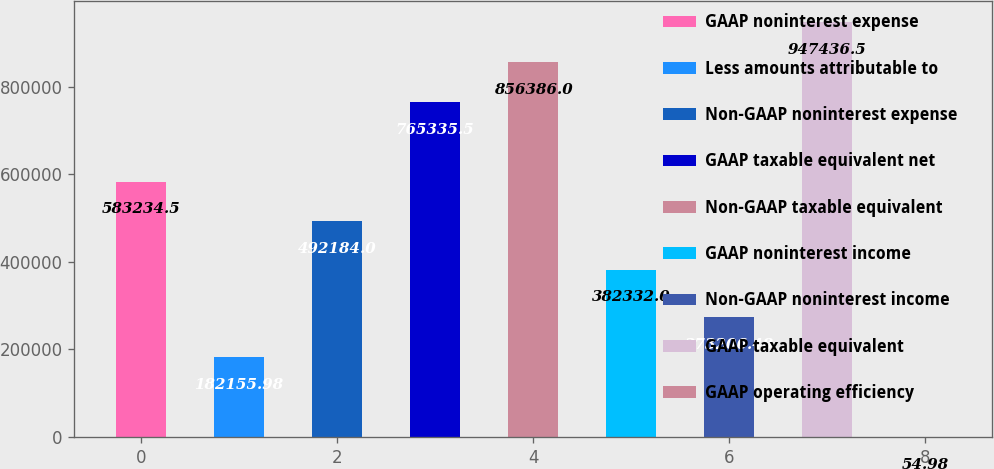<chart> <loc_0><loc_0><loc_500><loc_500><bar_chart><fcel>GAAP noninterest expense<fcel>Less amounts attributable to<fcel>Non-GAAP noninterest expense<fcel>GAAP taxable equivalent net<fcel>Non-GAAP taxable equivalent<fcel>GAAP noninterest income<fcel>Non-GAAP noninterest income<fcel>GAAP taxable equivalent<fcel>GAAP operating efficiency<nl><fcel>583234<fcel>182156<fcel>492184<fcel>765336<fcel>856386<fcel>382332<fcel>273206<fcel>947436<fcel>54.98<nl></chart> 